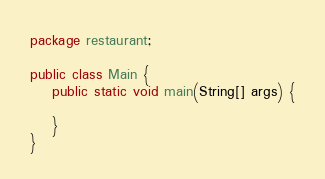Convert code to text. <code><loc_0><loc_0><loc_500><loc_500><_Java_>package restaurant;

public class Main {
    public static void main(String[] args) {

    }
}
</code> 